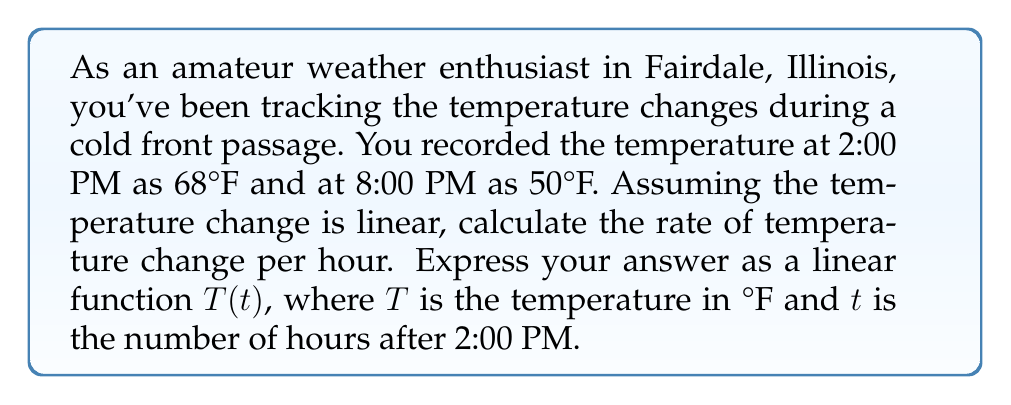Provide a solution to this math problem. Let's approach this step-by-step:

1) First, we need to identify our two points:
   At $t = 0$ (2:00 PM), $T = 68°F$
   At $t = 6$ (8:00 PM), $T = 50°F$

2) The linear function we're looking for has the form $T(t) = mt + b$, where:
   $m$ is the slope (rate of change)
   $b$ is the y-intercept (initial temperature)

3) To find the slope $m$, we use the formula:
   $$m = \frac{y_2 - y_1}{x_2 - x_1} = \frac{T_2 - T_1}{t_2 - t_1} = \frac{50 - 68}{6 - 0} = \frac{-18}{6} = -3$$

4) This means the temperature is decreasing by 3°F per hour.

5) Now that we have $m$, we can use either point to find $b$. Let's use the initial point:
   $68 = m(0) + b$
   $68 = b$

6) Therefore, our linear function is:
   $T(t) = -3t + 68$

This function gives us the temperature $T$ in °F, $t$ hours after 2:00 PM.
Answer: $T(t) = -3t + 68$, where $T$ is temperature in °F and $t$ is hours after 2:00 PM. 